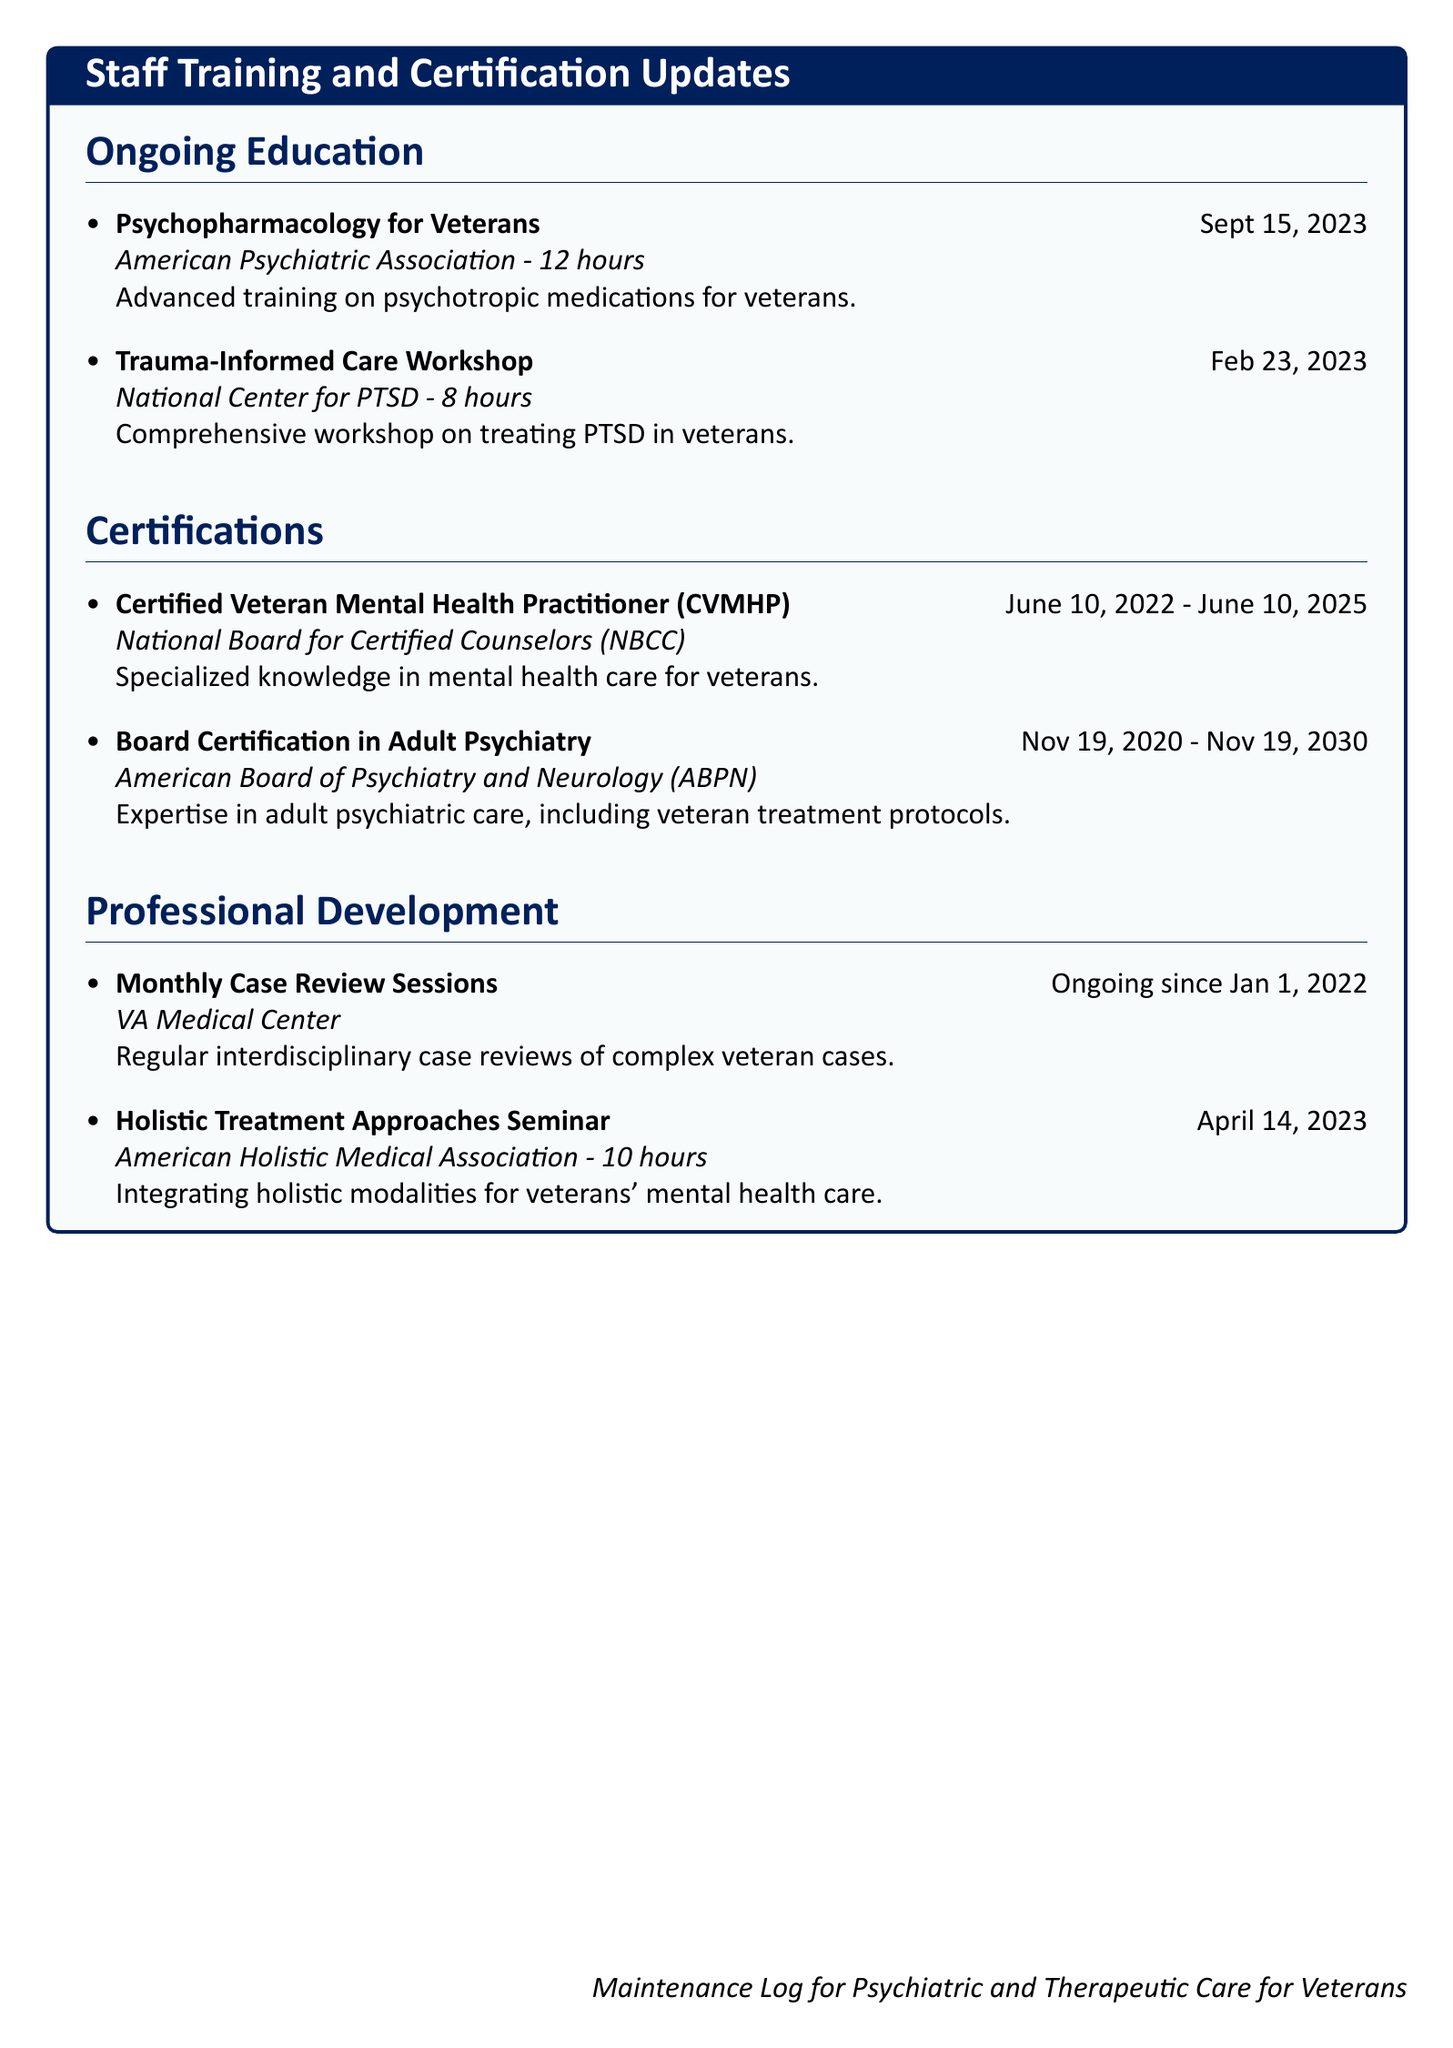What is the date of the Psychopharmacology for Veterans training? The date is listed under ongoing education.
Answer: Sept 15, 2023 How many hours is the Trauma-Informed Care Workshop? The total hours are specified alongside the training title.
Answer: 8 hours What certification is valid until June 10, 2025? The certification name and validity period are provided in the certifications section.
Answer: Certified Veteran Mental Health Practitioner (CVMHP) What organization provided the Holistic Treatment Approaches Seminar? The organizing body is mentioned in the professional development section.
Answer: American Holistic Medical Association How long has the Monthly Case Review Sessions been ongoing? The starting date indicates how long these sessions have been held.
Answer: Ongoing since Jan 1, 2022 What type of training does the psychiatrist have regarding veterans’ mental health? The document specifies the focus and relevance of the training undertaken.
Answer: Psychotropic medications for veterans How many total hours of ongoing education is listed in the document? The hours from each education entry need to be summed up.
Answer: 20 hours Which certification pertains to adult psychiatric care? The document lists this certification in the certifications section.
Answer: Board Certification in Adult Psychiatry 